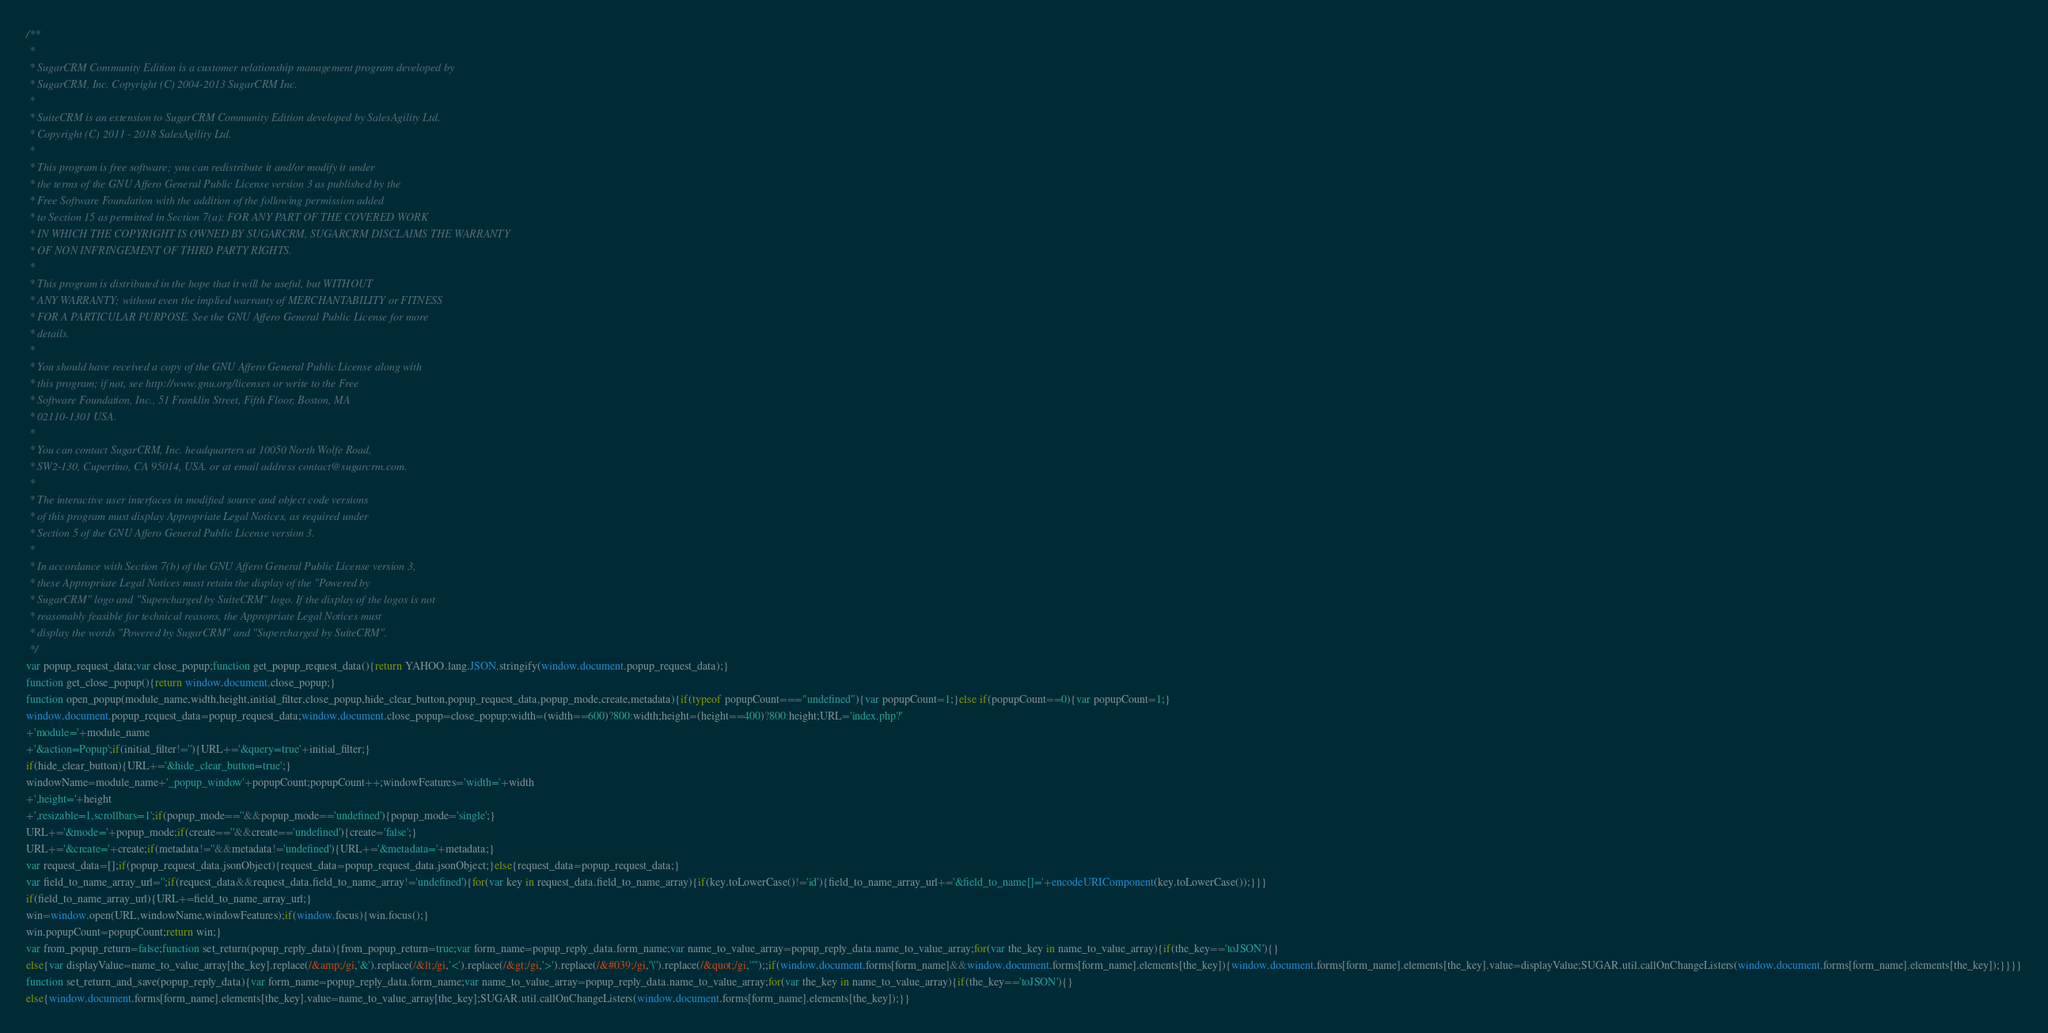<code> <loc_0><loc_0><loc_500><loc_500><_JavaScript_>/**
 *
 * SugarCRM Community Edition is a customer relationship management program developed by
 * SugarCRM, Inc. Copyright (C) 2004-2013 SugarCRM Inc.
 *
 * SuiteCRM is an extension to SugarCRM Community Edition developed by SalesAgility Ltd.
 * Copyright (C) 2011 - 2018 SalesAgility Ltd.
 *
 * This program is free software; you can redistribute it and/or modify it under
 * the terms of the GNU Affero General Public License version 3 as published by the
 * Free Software Foundation with the addition of the following permission added
 * to Section 15 as permitted in Section 7(a): FOR ANY PART OF THE COVERED WORK
 * IN WHICH THE COPYRIGHT IS OWNED BY SUGARCRM, SUGARCRM DISCLAIMS THE WARRANTY
 * OF NON INFRINGEMENT OF THIRD PARTY RIGHTS.
 *
 * This program is distributed in the hope that it will be useful, but WITHOUT
 * ANY WARRANTY; without even the implied warranty of MERCHANTABILITY or FITNESS
 * FOR A PARTICULAR PURPOSE. See the GNU Affero General Public License for more
 * details.
 *
 * You should have received a copy of the GNU Affero General Public License along with
 * this program; if not, see http://www.gnu.org/licenses or write to the Free
 * Software Foundation, Inc., 51 Franklin Street, Fifth Floor, Boston, MA
 * 02110-1301 USA.
 *
 * You can contact SugarCRM, Inc. headquarters at 10050 North Wolfe Road,
 * SW2-130, Cupertino, CA 95014, USA. or at email address contact@sugarcrm.com.
 *
 * The interactive user interfaces in modified source and object code versions
 * of this program must display Appropriate Legal Notices, as required under
 * Section 5 of the GNU Affero General Public License version 3.
 *
 * In accordance with Section 7(b) of the GNU Affero General Public License version 3,
 * these Appropriate Legal Notices must retain the display of the "Powered by
 * SugarCRM" logo and "Supercharged by SuiteCRM" logo. If the display of the logos is not
 * reasonably feasible for technical reasons, the Appropriate Legal Notices must
 * display the words "Powered by SugarCRM" and "Supercharged by SuiteCRM".
 */
var popup_request_data;var close_popup;function get_popup_request_data(){return YAHOO.lang.JSON.stringify(window.document.popup_request_data);}
function get_close_popup(){return window.document.close_popup;}
function open_popup(module_name,width,height,initial_filter,close_popup,hide_clear_button,popup_request_data,popup_mode,create,metadata){if(typeof popupCount==="undefined"){var popupCount=1;}else if(popupCount==0){var popupCount=1;}
window.document.popup_request_data=popup_request_data;window.document.close_popup=close_popup;width=(width==600)?800:width;height=(height==400)?800:height;URL='index.php?'
+'module='+module_name
+'&action=Popup';if(initial_filter!=''){URL+='&query=true'+initial_filter;}
if(hide_clear_button){URL+='&hide_clear_button=true';}
windowName=module_name+'_popup_window'+popupCount;popupCount++;windowFeatures='width='+width
+',height='+height
+',resizable=1,scrollbars=1';if(popup_mode==''&&popup_mode=='undefined'){popup_mode='single';}
URL+='&mode='+popup_mode;if(create==''&&create=='undefined'){create='false';}
URL+='&create='+create;if(metadata!=''&&metadata!='undefined'){URL+='&metadata='+metadata;}
var request_data=[];if(popup_request_data.jsonObject){request_data=popup_request_data.jsonObject;}else{request_data=popup_request_data;}
var field_to_name_array_url='';if(request_data&&request_data.field_to_name_array!='undefined'){for(var key in request_data.field_to_name_array){if(key.toLowerCase()!='id'){field_to_name_array_url+='&field_to_name[]='+encodeURIComponent(key.toLowerCase());}}}
if(field_to_name_array_url){URL+=field_to_name_array_url;}
win=window.open(URL,windowName,windowFeatures);if(window.focus){win.focus();}
win.popupCount=popupCount;return win;}
var from_popup_return=false;function set_return(popup_reply_data){from_popup_return=true;var form_name=popup_reply_data.form_name;var name_to_value_array=popup_reply_data.name_to_value_array;for(var the_key in name_to_value_array){if(the_key=='toJSON'){}
else{var displayValue=name_to_value_array[the_key].replace(/&amp;/gi,'&').replace(/&lt;/gi,'<').replace(/&gt;/gi,'>').replace(/&#039;/gi,'\'').replace(/&quot;/gi,'"');;if(window.document.forms[form_name]&&window.document.forms[form_name].elements[the_key]){window.document.forms[form_name].elements[the_key].value=displayValue;SUGAR.util.callOnChangeListers(window.document.forms[form_name].elements[the_key]);}}}}
function set_return_and_save(popup_reply_data){var form_name=popup_reply_data.form_name;var name_to_value_array=popup_reply_data.name_to_value_array;for(var the_key in name_to_value_array){if(the_key=='toJSON'){}
else{window.document.forms[form_name].elements[the_key].value=name_to_value_array[the_key];SUGAR.util.callOnChangeListers(window.document.forms[form_name].elements[the_key]);}}</code> 